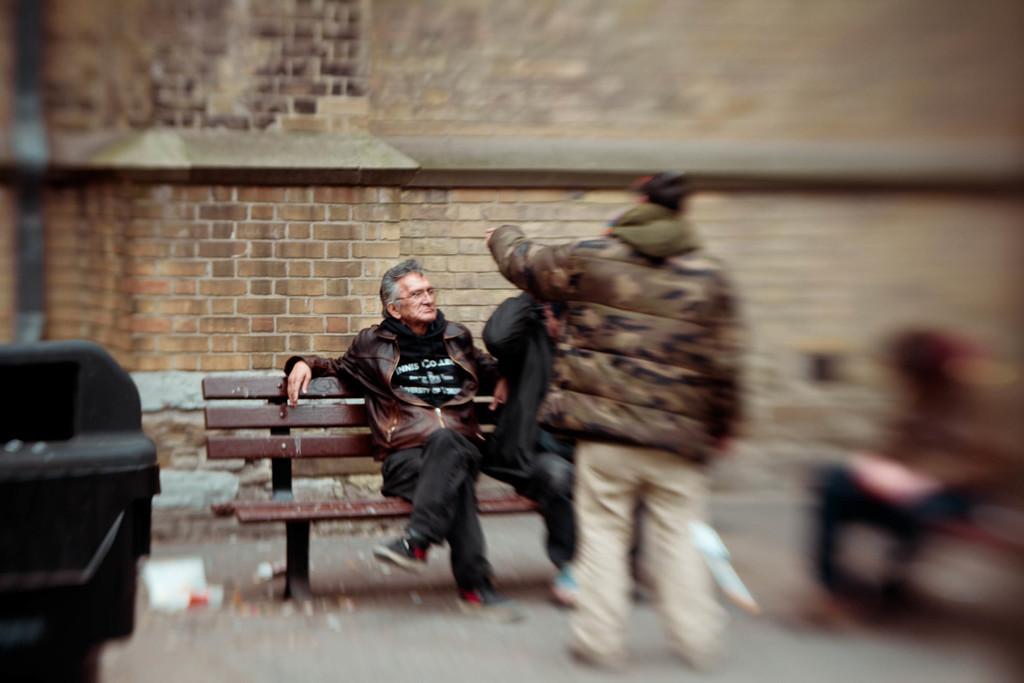In one or two sentences, can you explain what this image depicts? In this picture we can see an old man sitting on a bench in front of a brick wall. People beside him are out of focus in this image. 